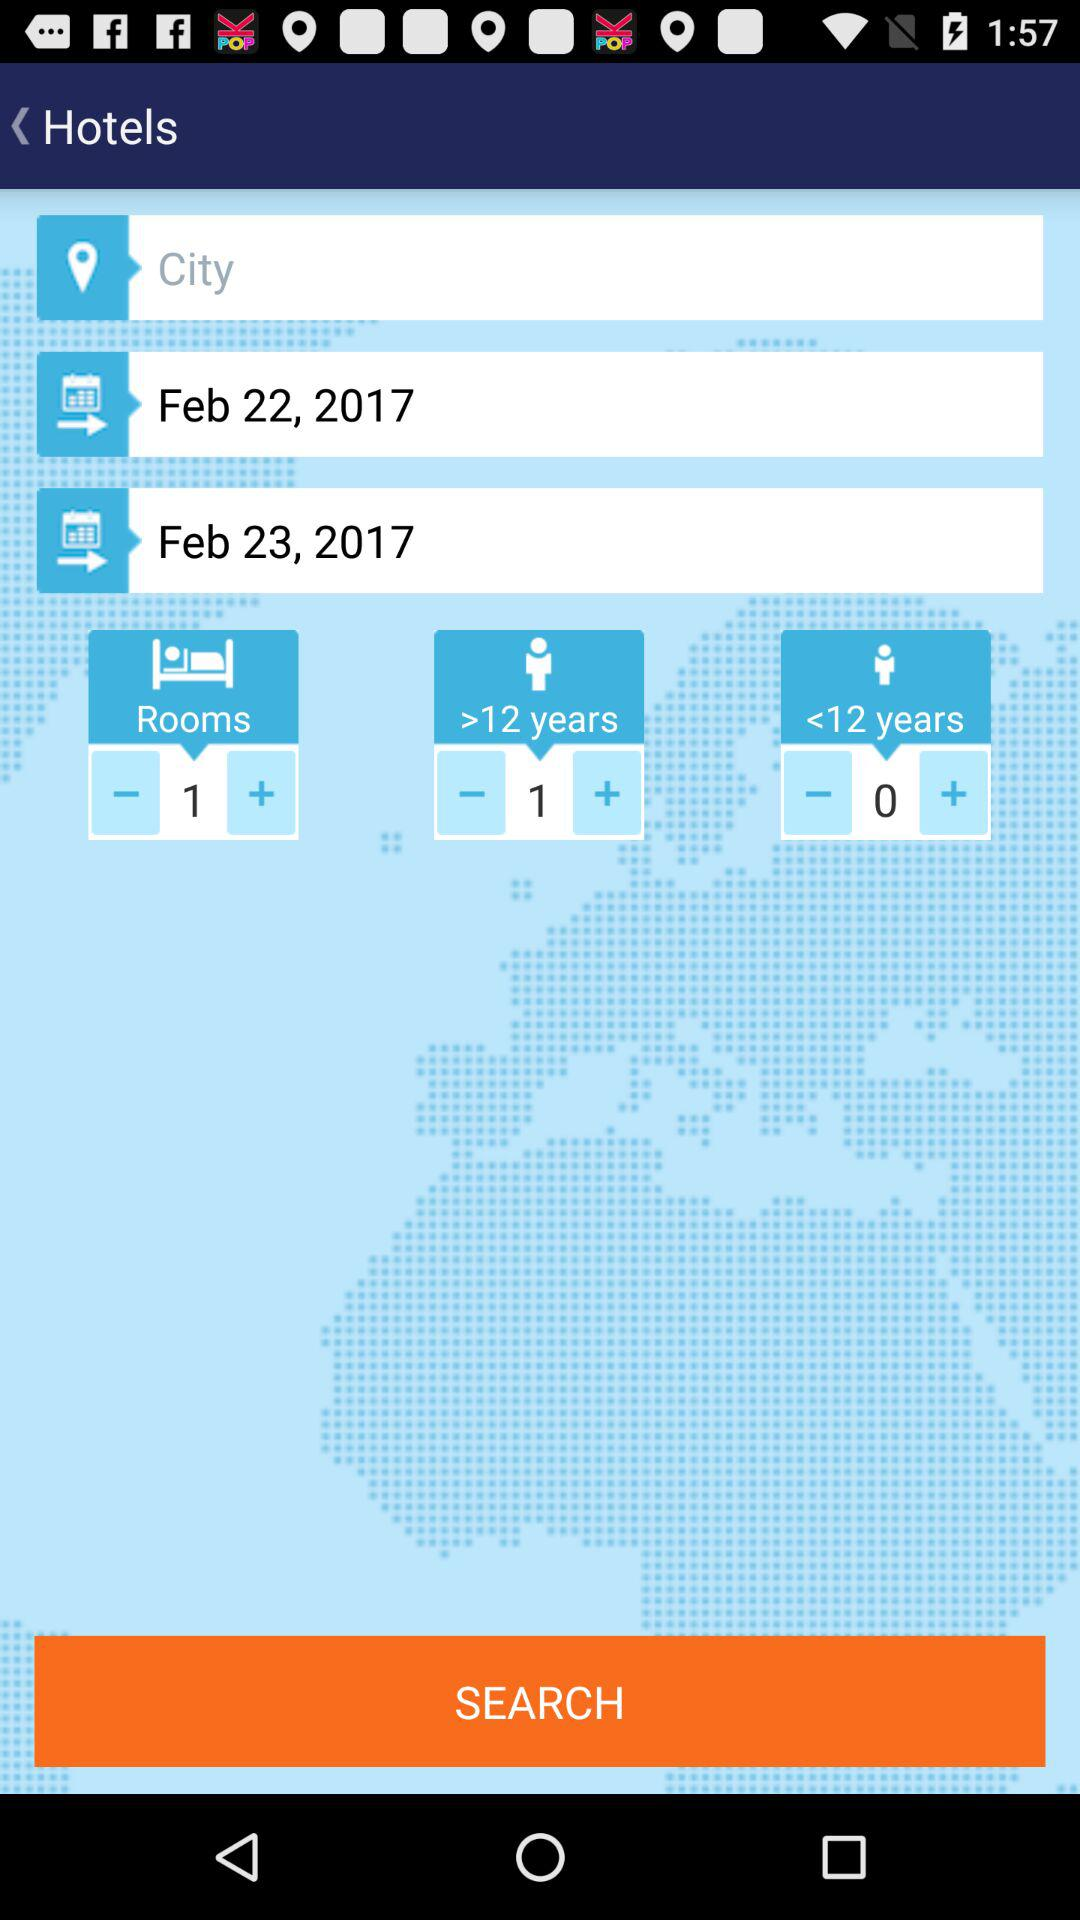How many days apart are the two check-in dates?
Answer the question using a single word or phrase. 1 